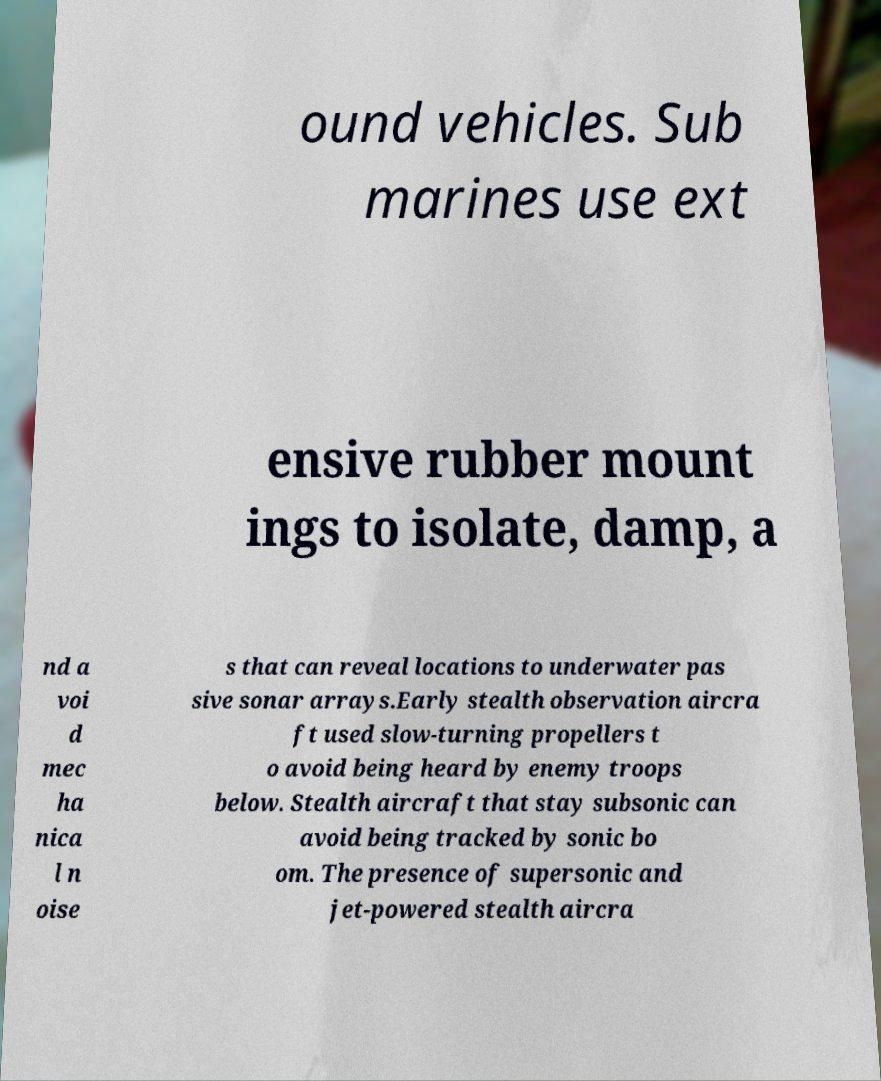Could you assist in decoding the text presented in this image and type it out clearly? ound vehicles. Sub marines use ext ensive rubber mount ings to isolate, damp, a nd a voi d mec ha nica l n oise s that can reveal locations to underwater pas sive sonar arrays.Early stealth observation aircra ft used slow-turning propellers t o avoid being heard by enemy troops below. Stealth aircraft that stay subsonic can avoid being tracked by sonic bo om. The presence of supersonic and jet-powered stealth aircra 